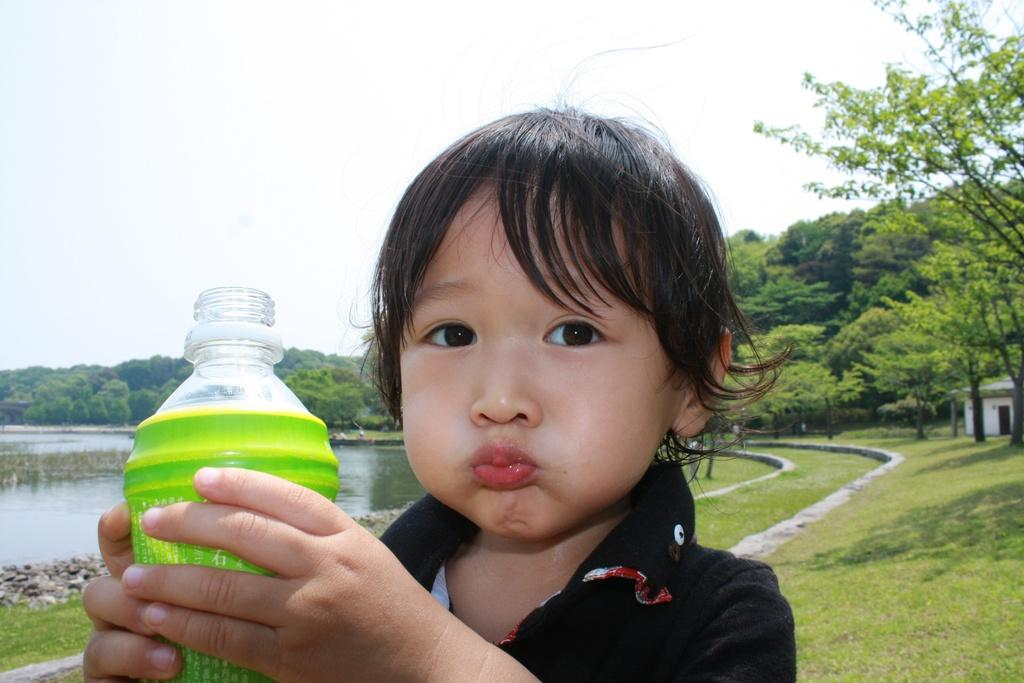What is the main subject of the image? There is a child in the image. What is the child holding in the image? The child is holding a bottle. What type of natural environment can be seen in the image? There are trees and water visible in the image. What type of popcorn can be seen floating on the water in the image? There is no popcorn present in the image, and therefore no such activity can be observed. 